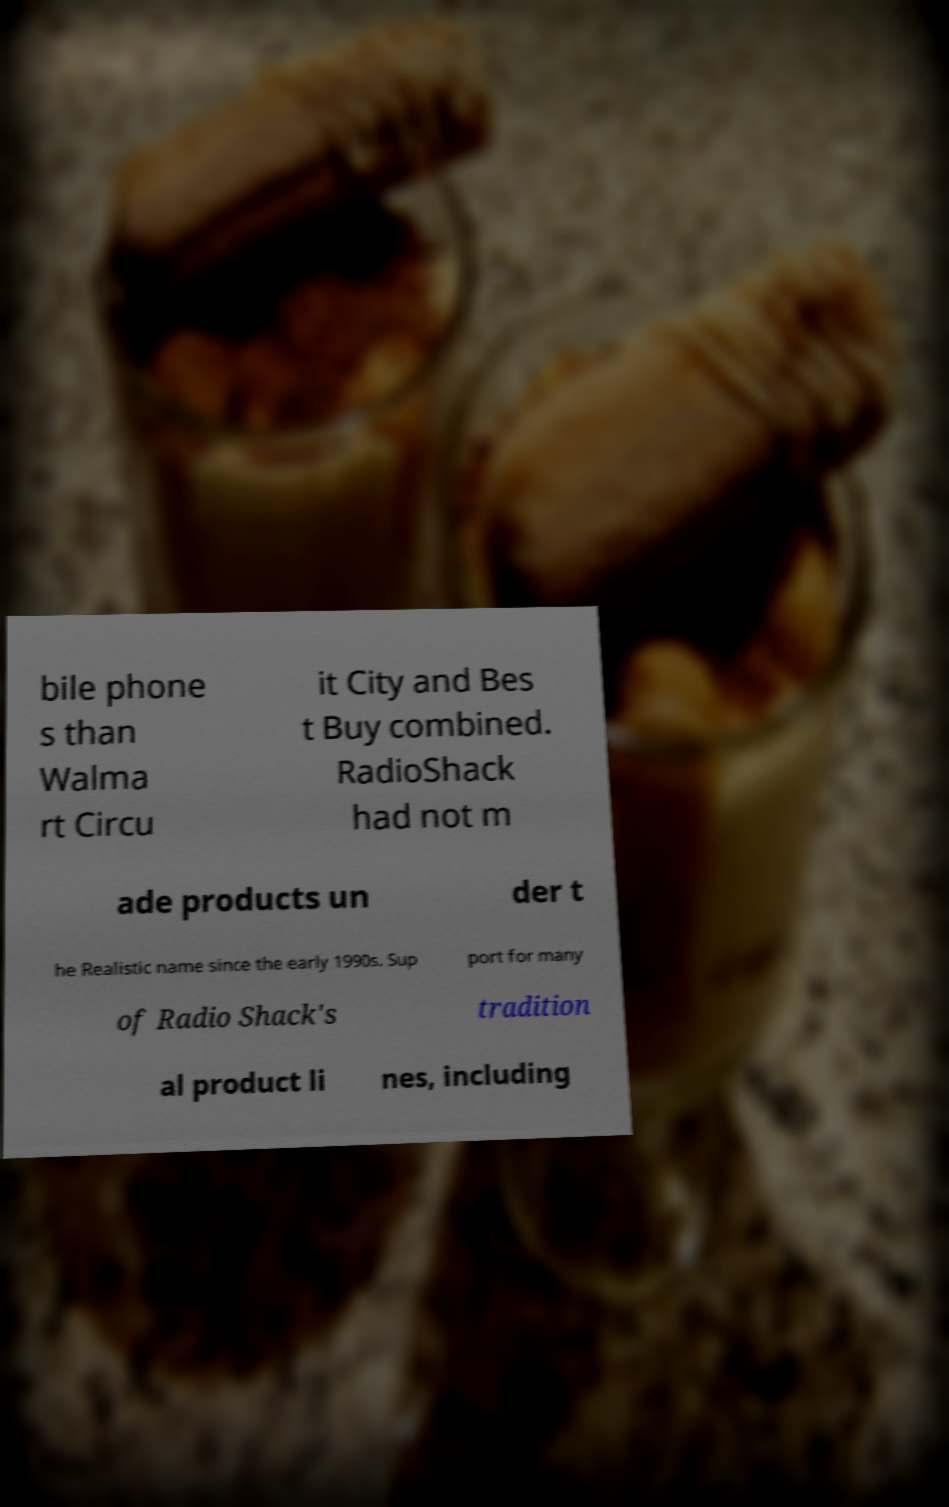I need the written content from this picture converted into text. Can you do that? bile phone s than Walma rt Circu it City and Bes t Buy combined. RadioShack had not m ade products un der t he Realistic name since the early 1990s. Sup port for many of Radio Shack's tradition al product li nes, including 